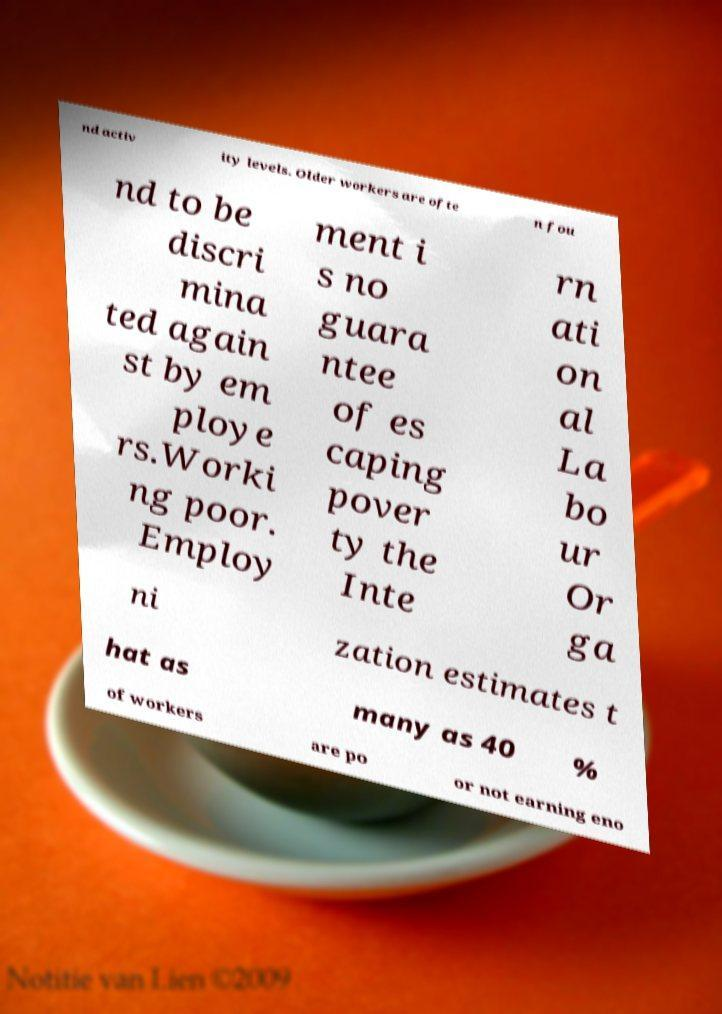Could you extract and type out the text from this image? nd activ ity levels. Older workers are ofte n fou nd to be discri mina ted again st by em ploye rs.Worki ng poor. Employ ment i s no guara ntee of es caping pover ty the Inte rn ati on al La bo ur Or ga ni zation estimates t hat as many as 40 % of workers are po or not earning eno 